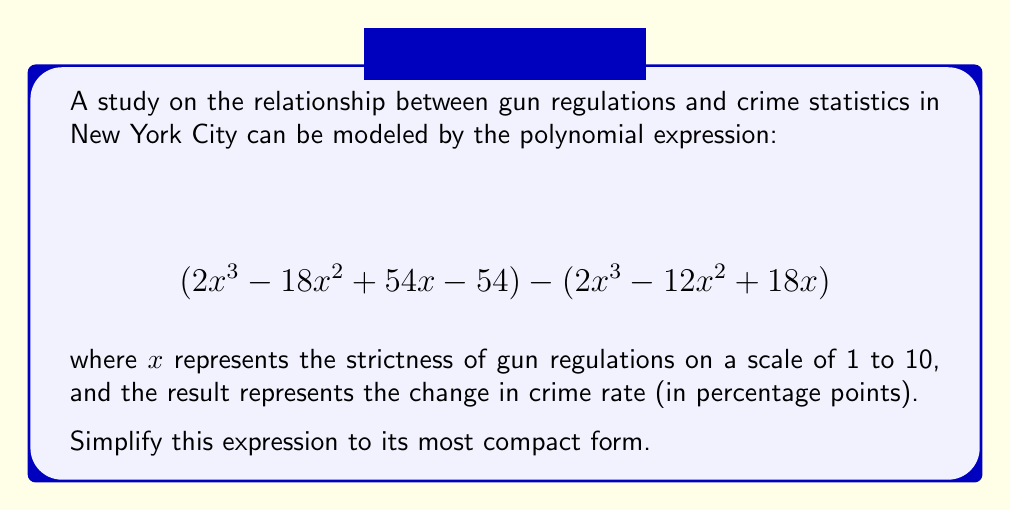Solve this math problem. To simplify this polynomial expression, we'll follow these steps:

1) First, let's distribute the negative sign to the second polynomial:
   $$(2x^3 - 18x^2 + 54x - 54) + (-2x^3 + 12x^2 - 18x)$$

2) Now, we can combine like terms:

   For $x^3$ terms: $2x^3 + (-2x^3) = 0$
   
   For $x^2$ terms: $-18x^2 + 12x^2 = -6x^2$
   
   For $x$ terms: $54x + (-18x) = 36x$
   
   Constant term: $-54$

3) Putting it all together, we get:

   $$-6x^2 + 36x - 54$$

4) We can factor out the greatest common factor (GCF):
   
   The GCF of all terms is 6.

   $$-6(x^2 - 6x + 9)$$

5) The quadratic expression inside the parentheses can be factored further:

   $$-6(x - 3)(x - 3)$$

6) This can be written as:

   $$-6(x - 3)^2$$

This is the most simplified form of the original expression.
Answer: $$-6(x - 3)^2$$ 